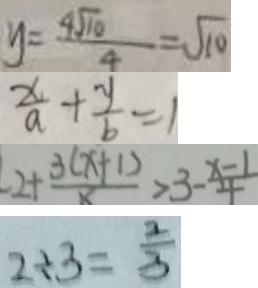Convert formula to latex. <formula><loc_0><loc_0><loc_500><loc_500>y = \frac { 4 \sqrt { 1 0 } } { 4 } = \sqrt { 1 0 } 
 \frac { x } { a } + \frac { y } { b } = 1 
 2 + \frac { 3 ( x + 1 ) } { x } > 3 - \frac { x - 1 } { 4 } 
 2 \div 3 = \frac { 2 } { 3 }</formula> 